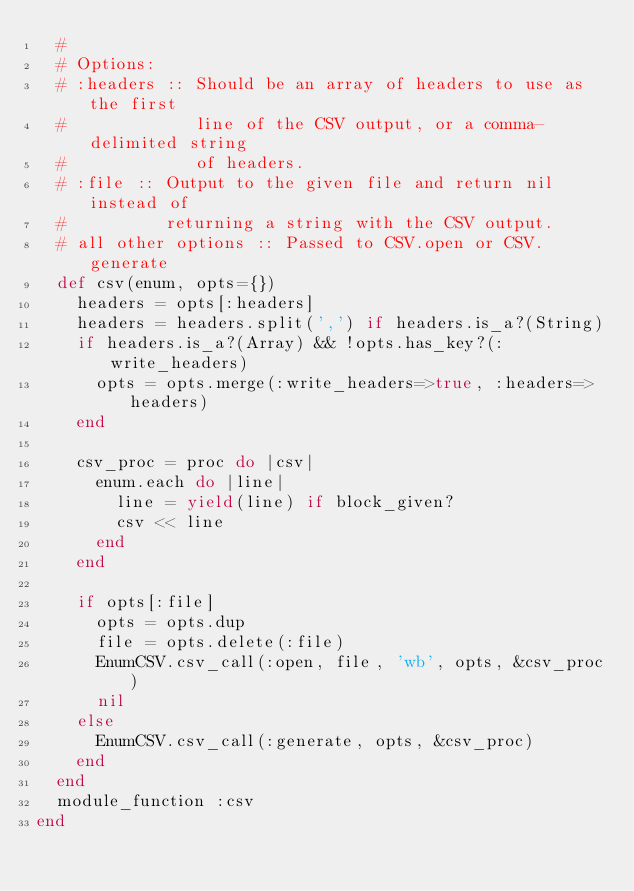Convert code to text. <code><loc_0><loc_0><loc_500><loc_500><_Ruby_>  #
  # Options:
  # :headers :: Should be an array of headers to use as the first
  #             line of the CSV output, or a comma-delimited string
  #             of headers.
  # :file :: Output to the given file and return nil instead of
  #          returning a string with the CSV output.
  # all other options :: Passed to CSV.open or CSV.generate
  def csv(enum, opts={})
    headers = opts[:headers]
    headers = headers.split(',') if headers.is_a?(String)
    if headers.is_a?(Array) && !opts.has_key?(:write_headers)
      opts = opts.merge(:write_headers=>true, :headers=>headers)
    end

    csv_proc = proc do |csv|
      enum.each do |line|
        line = yield(line) if block_given?
        csv << line
      end
    end

    if opts[:file]
      opts = opts.dup
      file = opts.delete(:file)
      EnumCSV.csv_call(:open, file, 'wb', opts, &csv_proc)
      nil
    else
      EnumCSV.csv_call(:generate, opts, &csv_proc)
    end
  end
  module_function :csv
end
</code> 